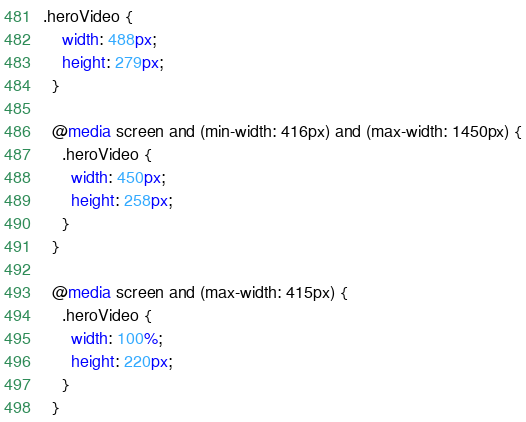<code> <loc_0><loc_0><loc_500><loc_500><_CSS_>.heroVideo {
    width: 488px;
    height: 279px;
  }
  
  @media screen and (min-width: 416px) and (max-width: 1450px) {
    .heroVideo {
      width: 450px;
      height: 258px;
    }
  }
  
  @media screen and (max-width: 415px) {
    .heroVideo {
      width: 100%;
      height: 220px;
    }
  }</code> 